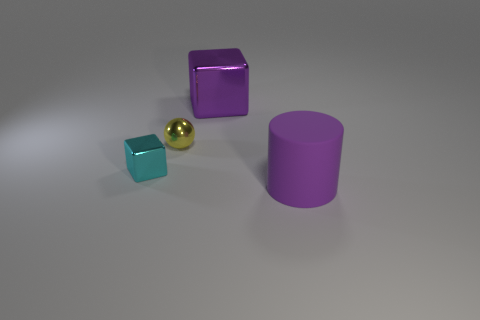Add 2 matte objects. How many objects exist? 6 Subtract all balls. How many objects are left? 3 Subtract all yellow matte things. Subtract all purple rubber cylinders. How many objects are left? 3 Add 1 small balls. How many small balls are left? 2 Add 1 small cyan objects. How many small cyan objects exist? 2 Subtract 0 blue cubes. How many objects are left? 4 